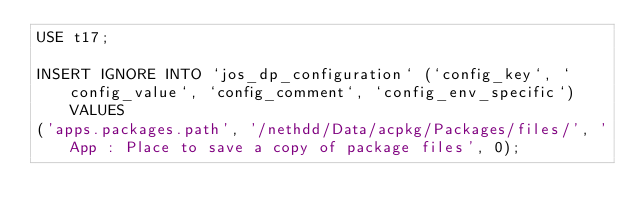<code> <loc_0><loc_0><loc_500><loc_500><_SQL_>USE t17;

INSERT IGNORE INTO `jos_dp_configuration` (`config_key`, `config_value`, `config_comment`, `config_env_specific`) VALUES
('apps.packages.path', '/nethdd/Data/acpkg/Packages/files/', 'App : Place to save a copy of package files', 0);
</code> 